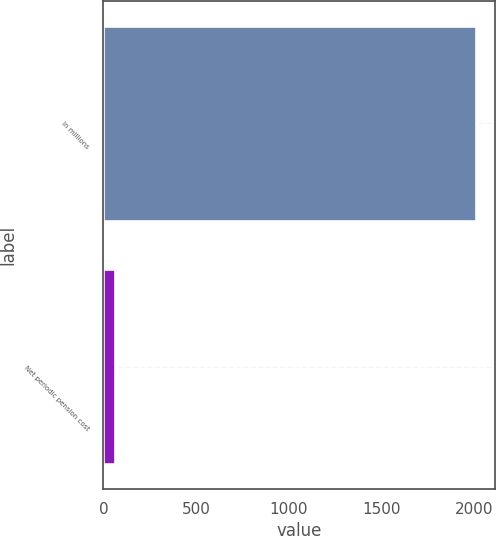Convert chart to OTSL. <chart><loc_0><loc_0><loc_500><loc_500><bar_chart><fcel>In millions<fcel>Net periodic pension cost<nl><fcel>2012<fcel>64<nl></chart> 